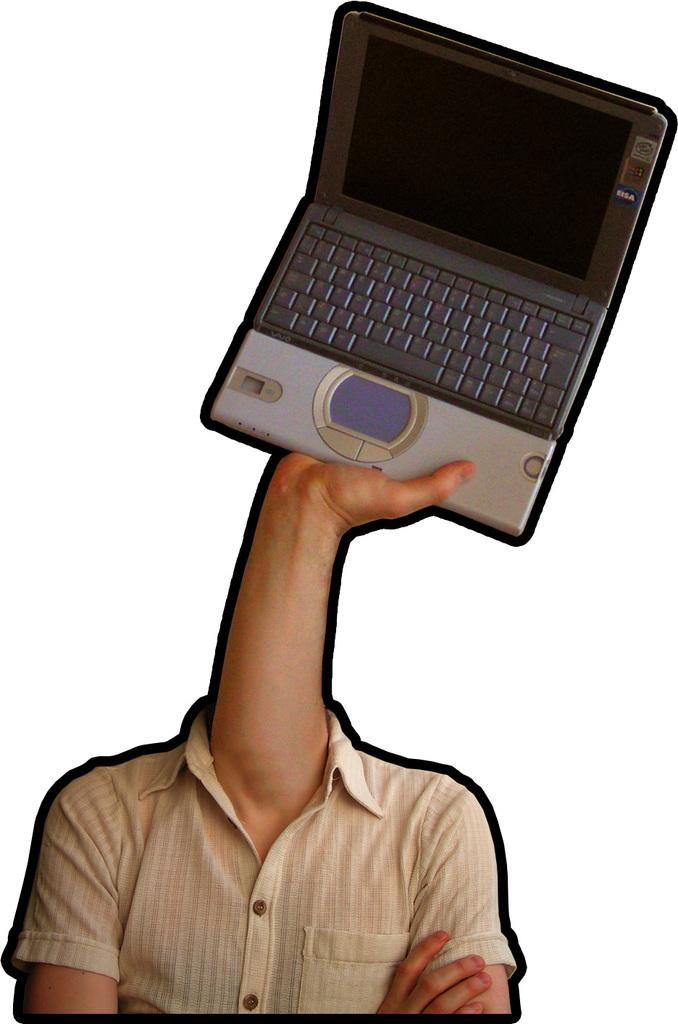What type of image is being described? The image is an edited picture. What is the main subject of the image? A hand of a person is holding a laptop. What else can be seen in the image besides the laptop? There is a shirt visible in the image. Are there any other hands present in the image? Yes, there is another hand in the image. What is the color of the background in the image? The background color is white. What type of fear can be seen on the person's face in the image? There is no person's face visible in the image, as it only shows a hand holding a laptop and another hand. What type of roof is visible in the image? There is no roof present in the image; it only features a hand holding a laptop, a shirt, and another hand. 